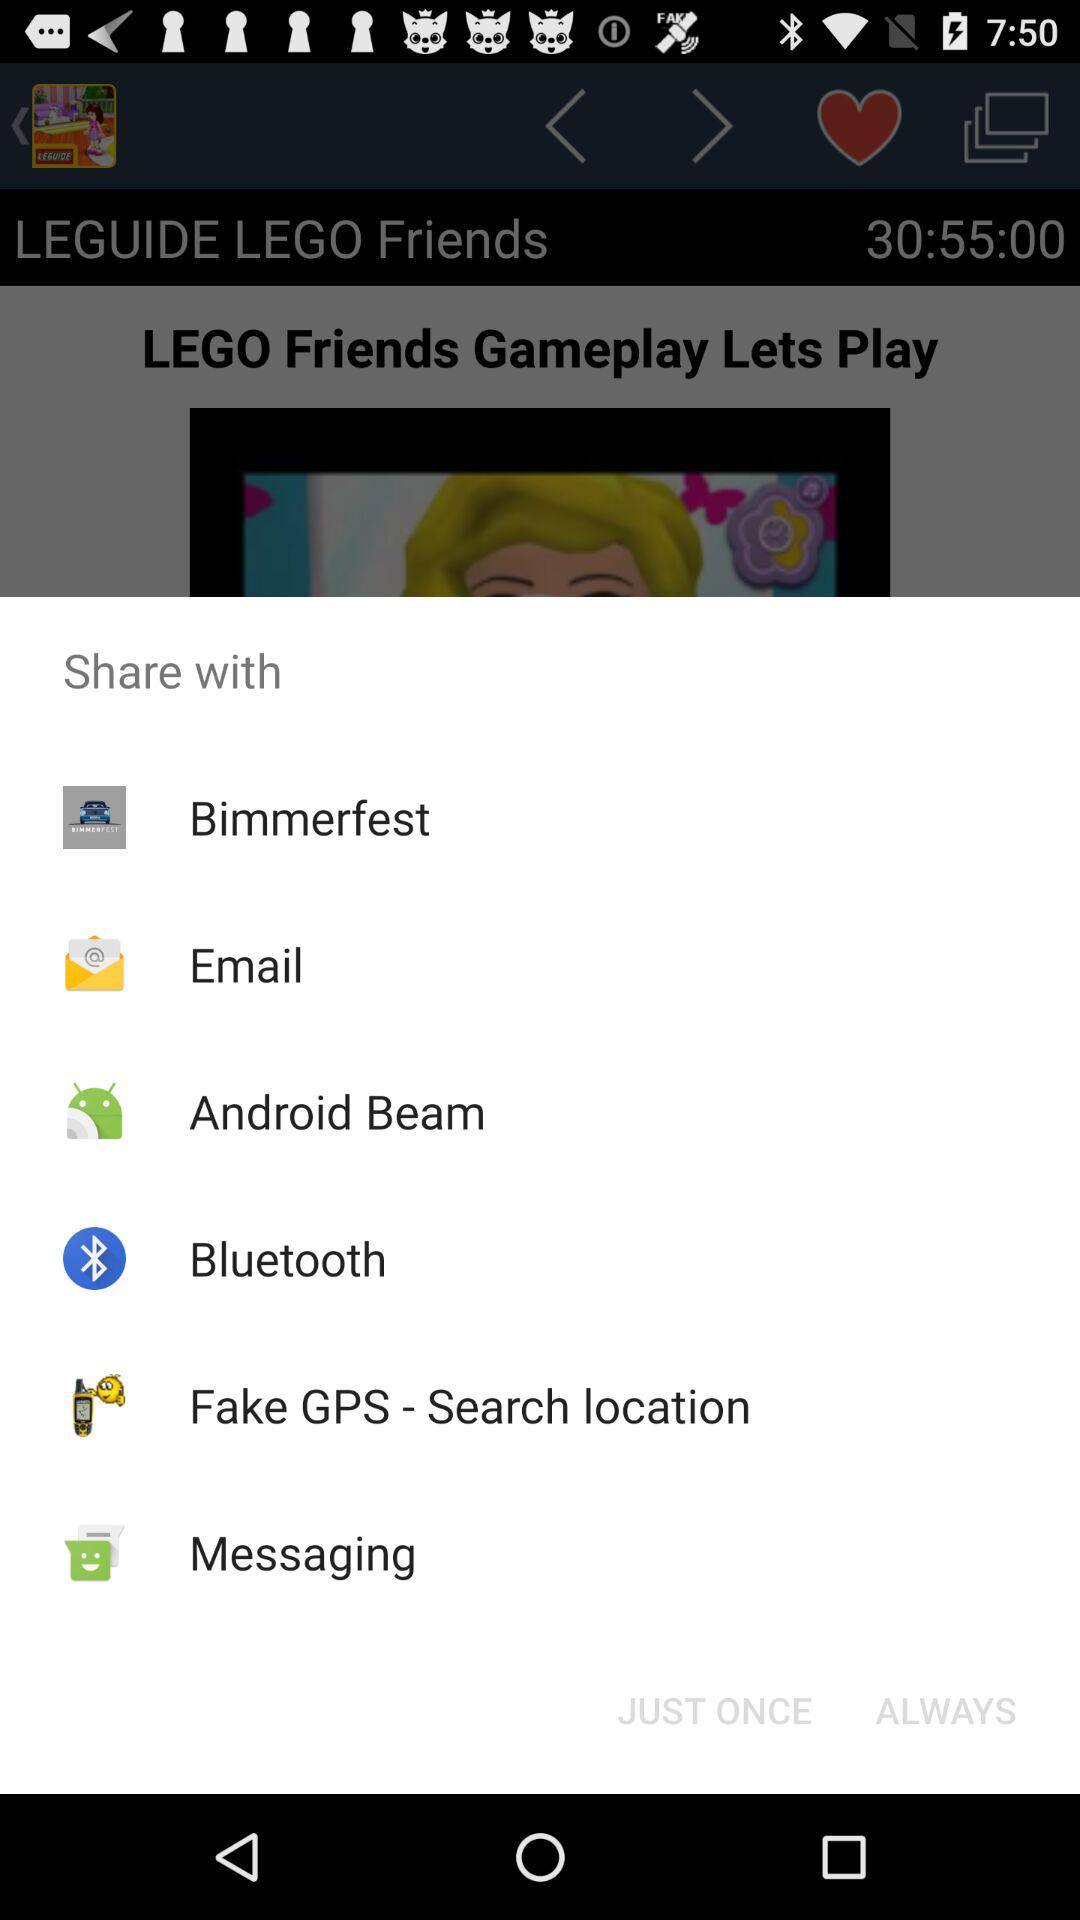Through which application can we share the content? The applications are "Bimmerfest", "Android Beam", "Bluetooth", "Fake GPS - Search location" and "Messaging". 